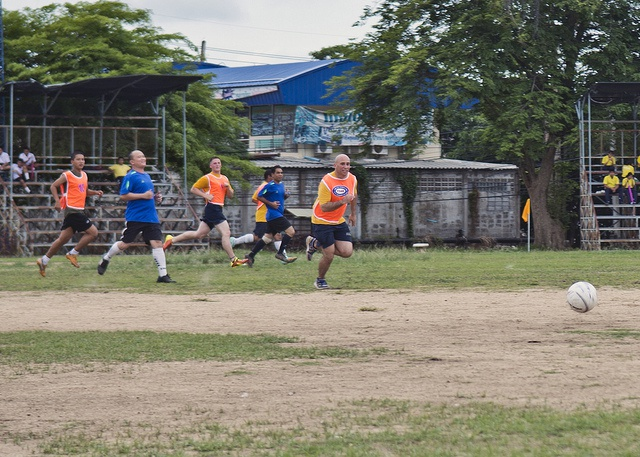Describe the objects in this image and their specific colors. I can see bench in darkgray, gray, and black tones, people in darkgray, gray, black, and orange tones, people in darkgray, black, blue, and gray tones, people in darkgray, gray, black, and lightpink tones, and people in darkgray, black, gray, and salmon tones in this image. 